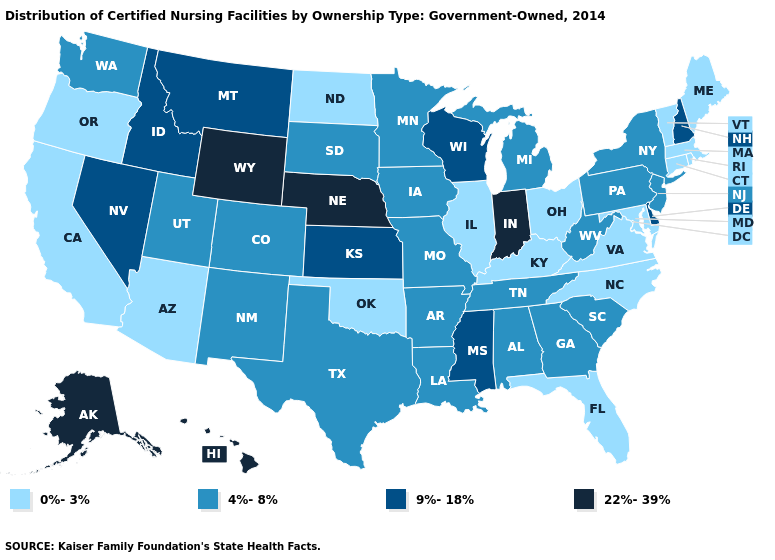Among the states that border Wisconsin , does Illinois have the highest value?
Keep it brief. No. Name the states that have a value in the range 0%-3%?
Be succinct. Arizona, California, Connecticut, Florida, Illinois, Kentucky, Maine, Maryland, Massachusetts, North Carolina, North Dakota, Ohio, Oklahoma, Oregon, Rhode Island, Vermont, Virginia. How many symbols are there in the legend?
Quick response, please. 4. What is the highest value in the USA?
Write a very short answer. 22%-39%. Does Connecticut have the lowest value in the USA?
Keep it brief. Yes. Does South Dakota have a higher value than California?
Give a very brief answer. Yes. What is the lowest value in the MidWest?
Give a very brief answer. 0%-3%. Does the first symbol in the legend represent the smallest category?
Concise answer only. Yes. Name the states that have a value in the range 9%-18%?
Short answer required. Delaware, Idaho, Kansas, Mississippi, Montana, Nevada, New Hampshire, Wisconsin. What is the lowest value in the Northeast?
Quick response, please. 0%-3%. Which states have the lowest value in the Northeast?
Answer briefly. Connecticut, Maine, Massachusetts, Rhode Island, Vermont. Does Hawaii have the highest value in the USA?
Write a very short answer. Yes. What is the lowest value in the Northeast?
Be succinct. 0%-3%. Name the states that have a value in the range 4%-8%?
Give a very brief answer. Alabama, Arkansas, Colorado, Georgia, Iowa, Louisiana, Michigan, Minnesota, Missouri, New Jersey, New Mexico, New York, Pennsylvania, South Carolina, South Dakota, Tennessee, Texas, Utah, Washington, West Virginia. Name the states that have a value in the range 22%-39%?
Short answer required. Alaska, Hawaii, Indiana, Nebraska, Wyoming. 